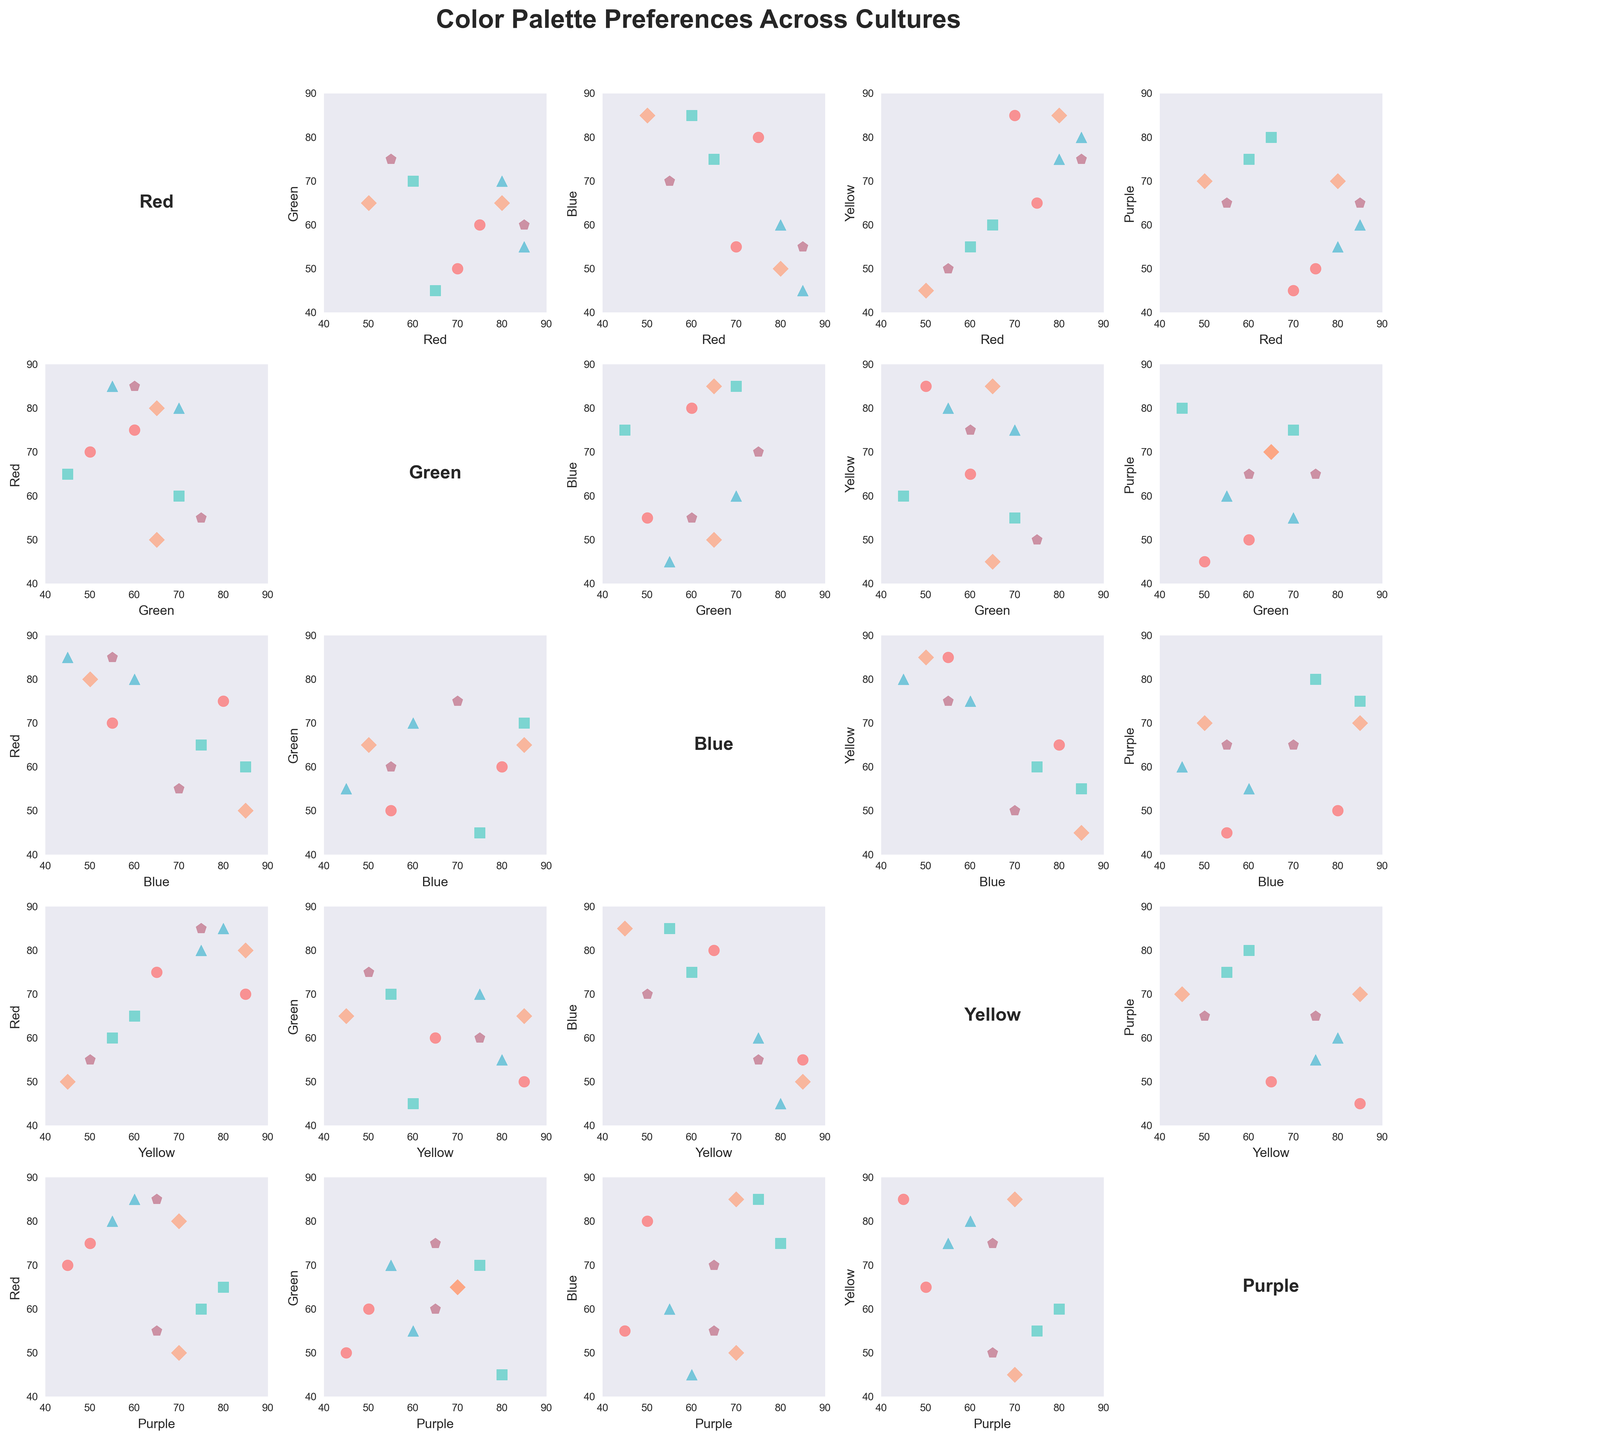What are the axes labels in the scatterplot matrix figure? Each subplot in the scatterplot matrix figure has its axes labeled with one of the color palettes. For example, one subplot might have "Red" on the x-axis and "Green" on the y-axis.
Answer: Red, Green, Blue, Yellow, Purple Which culture appears to prefer red the most? Looking at the scatter points in the subplots involving “Red,” we can see that Mexico and Italy have high values for red compared to other cultures. Both have a red preference of 85, but none is markedly above the other.
Answer: Mexico and Italy Which culture seems least to prefer blue? By observing the scatter points along "Blue" in various subplots, Mexico has the lowest value of 45, indicating the least preference for blue.
Answer: Mexico How does the preference for yellow compare between India and Nigeria? In the subplots where yellow is on the axis, Nigeria and India can be compared. Nigeria and India both show a preference of 85 for yellow, making them equal in this preference.
Answer: Equal What are the purple preference values for South Korea and Brazil? In the scatter points of subplots that involve purple, we can see that South Korea has a purple preference value of 70, while Brazil has a preference value of 55.
Answer: South Korea: 70, Brazil: 55 Which two cultures have similar preferences for green? Observing the scatter points where green is plotted, Japan and Brazil show very close preferences for green, both at 70, making their preferences quite similar.
Answer: Japan and Brazil Which color shows the widest range of preferences across the cultures? By examining the spread of scatter points along each color axis, we notice that red ranges from 50 to 85, indicating it has the widest range of preferences across different cultures.
Answer: Red Between Red and Yellow, which culture shows a higher correlation in preference values, and what does it signify? By observing the scatterplot between Red and Yellow, and comparing the clustering of points, it can be inferred that cultures with similar preferences in one have less spread in the other. Brazil and India, for example, both show high preferences for both colors, suggesting a higher correlation between these two cultures' preferences for Red and Yellow.
Answer: Brazil and India Is there a culture that shows low preference for both Green and Purple? Syria's green preference (45) and purple (45) scatter points indicate low preferences for both colors compared to other cultures.
Answer: Russia 